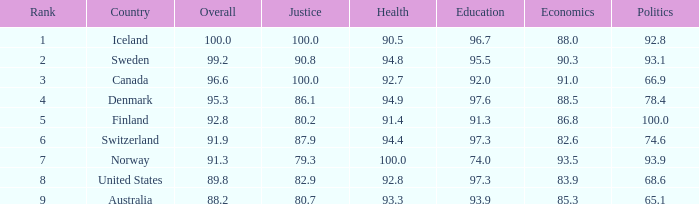7? 93.3. 